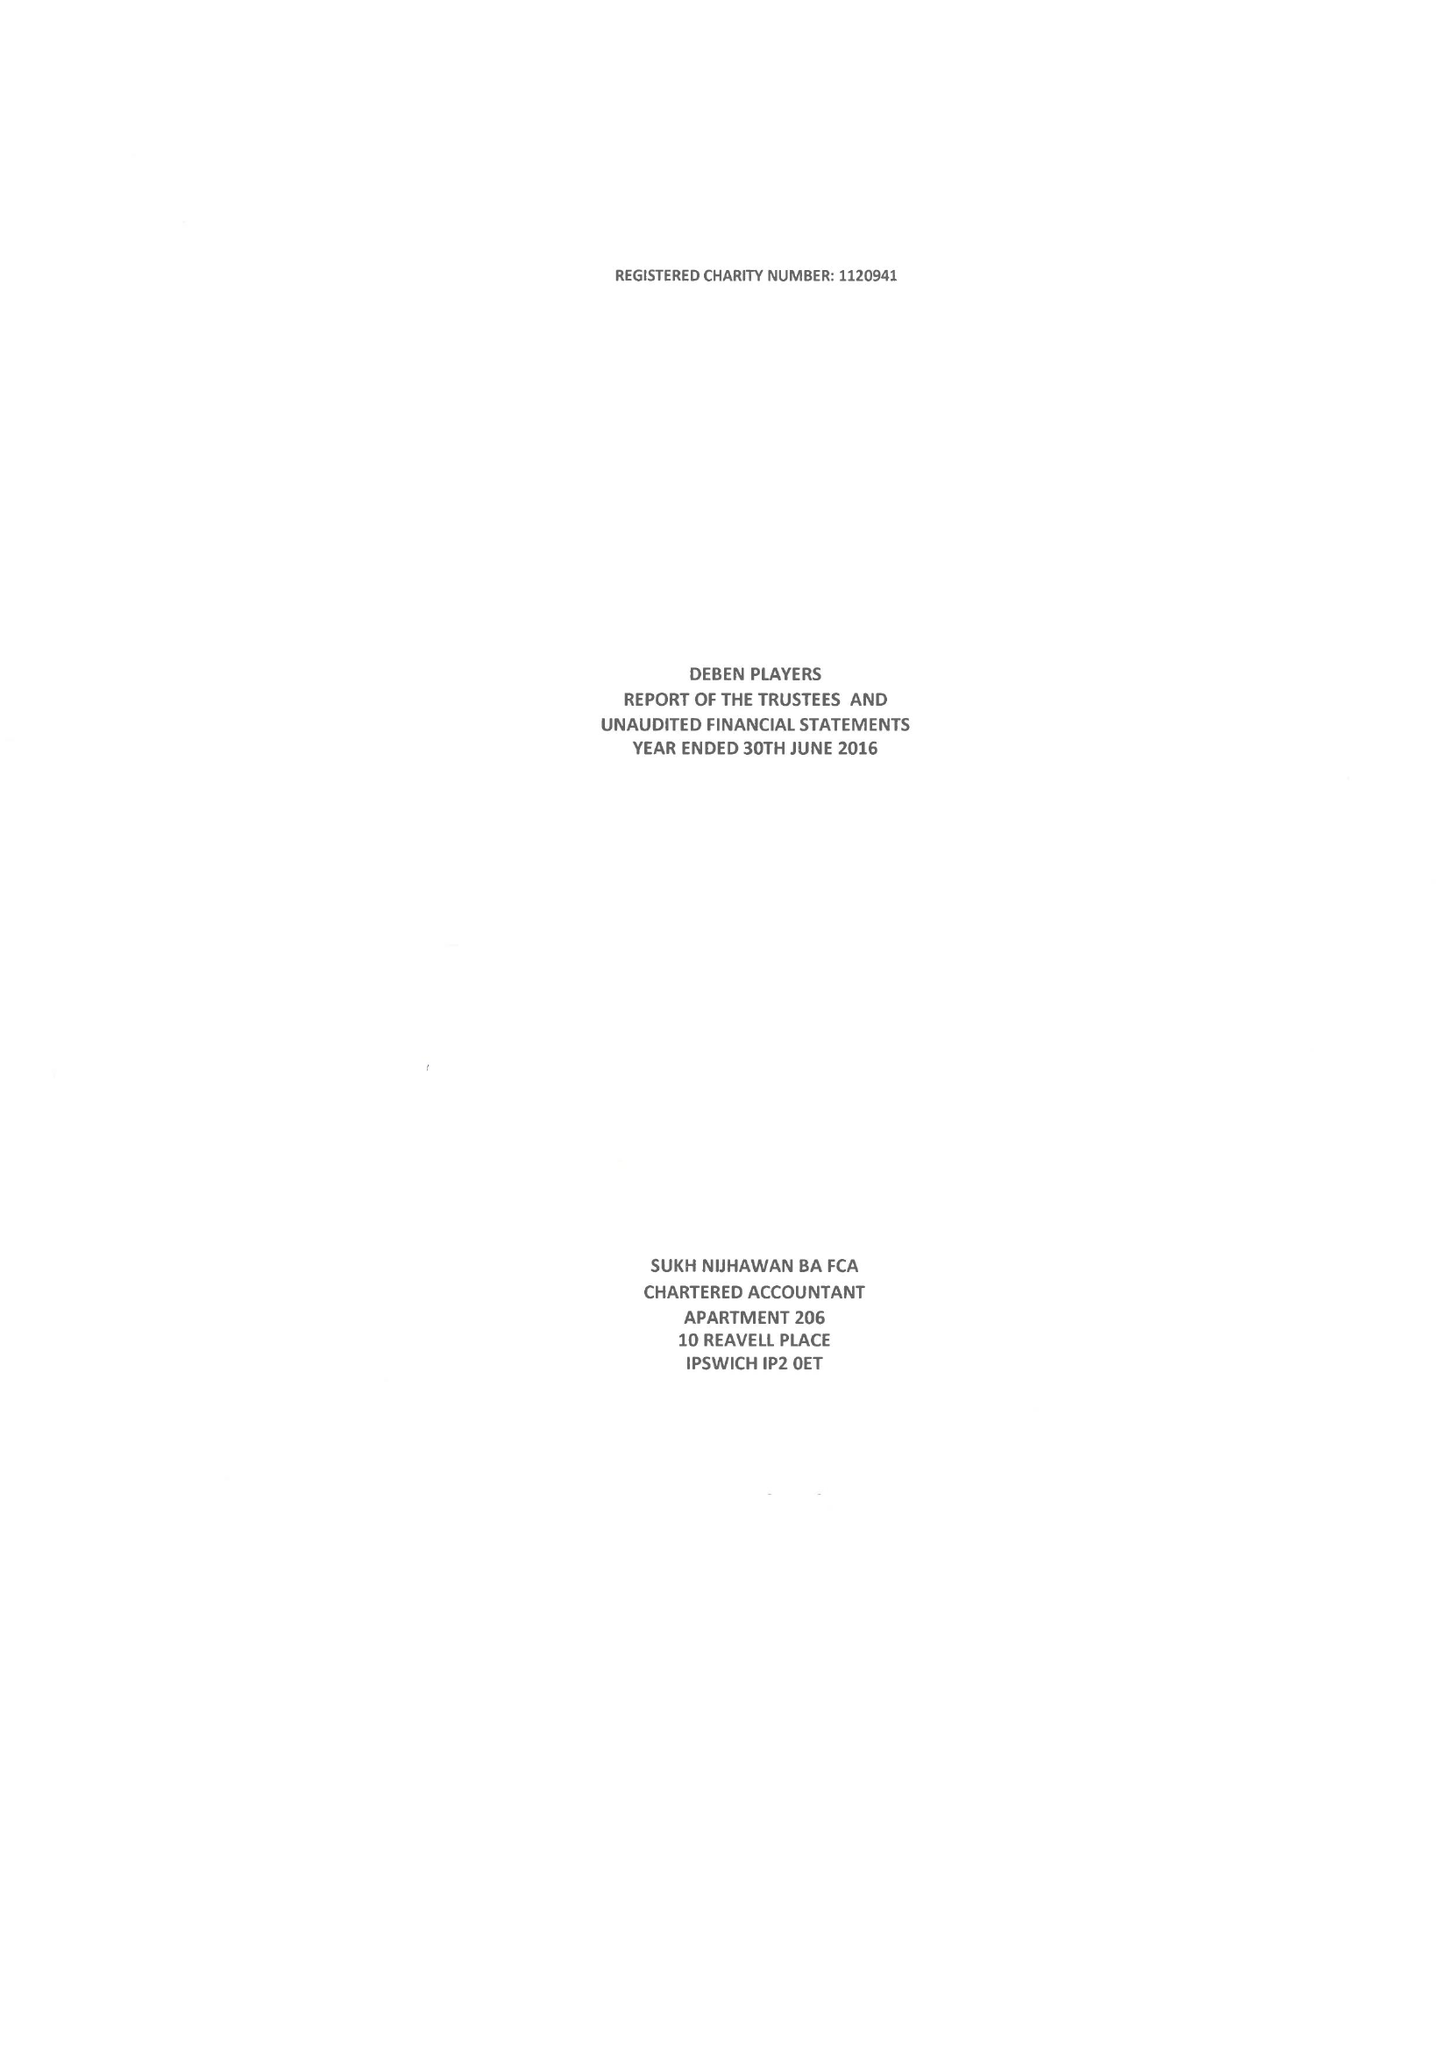What is the value for the address__postcode?
Answer the question using a single word or phrase. IP11 7SA 